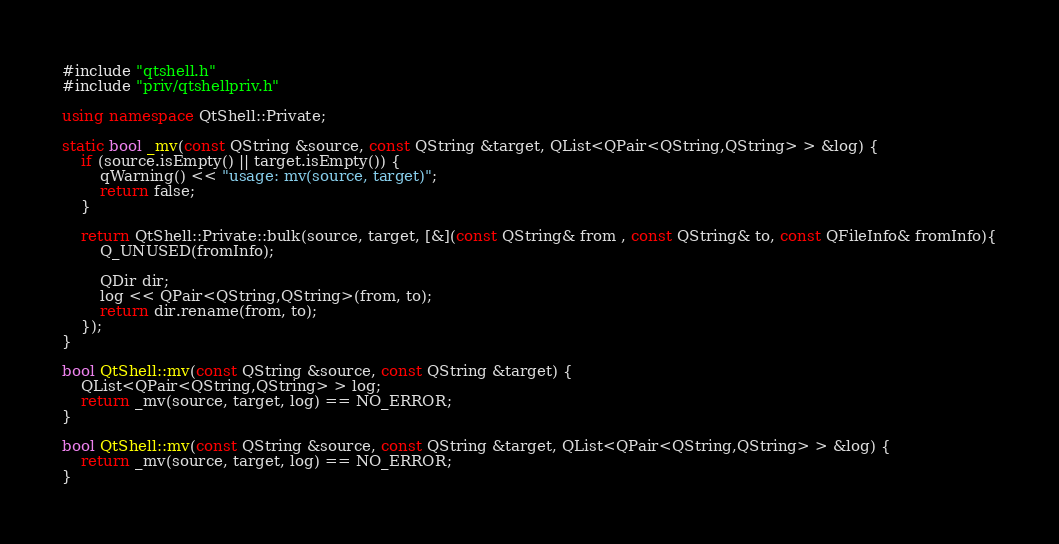<code> <loc_0><loc_0><loc_500><loc_500><_C++_>#include "qtshell.h"
#include "priv/qtshellpriv.h"

using namespace QtShell::Private;

static bool _mv(const QString &source, const QString &target, QList<QPair<QString,QString> > &log) {
    if (source.isEmpty() || target.isEmpty()) {
        qWarning() << "usage: mv(source, target)";
        return false;
    }

    return QtShell::Private::bulk(source, target, [&](const QString& from , const QString& to, const QFileInfo& fromInfo){
        Q_UNUSED(fromInfo);

        QDir dir;
        log << QPair<QString,QString>(from, to);
        return dir.rename(from, to);
    });
}

bool QtShell::mv(const QString &source, const QString &target) {
    QList<QPair<QString,QString> > log;
    return _mv(source, target, log) == NO_ERROR;
}

bool QtShell::mv(const QString &source, const QString &target, QList<QPair<QString,QString> > &log) {
    return _mv(source, target, log) == NO_ERROR;
}
</code> 